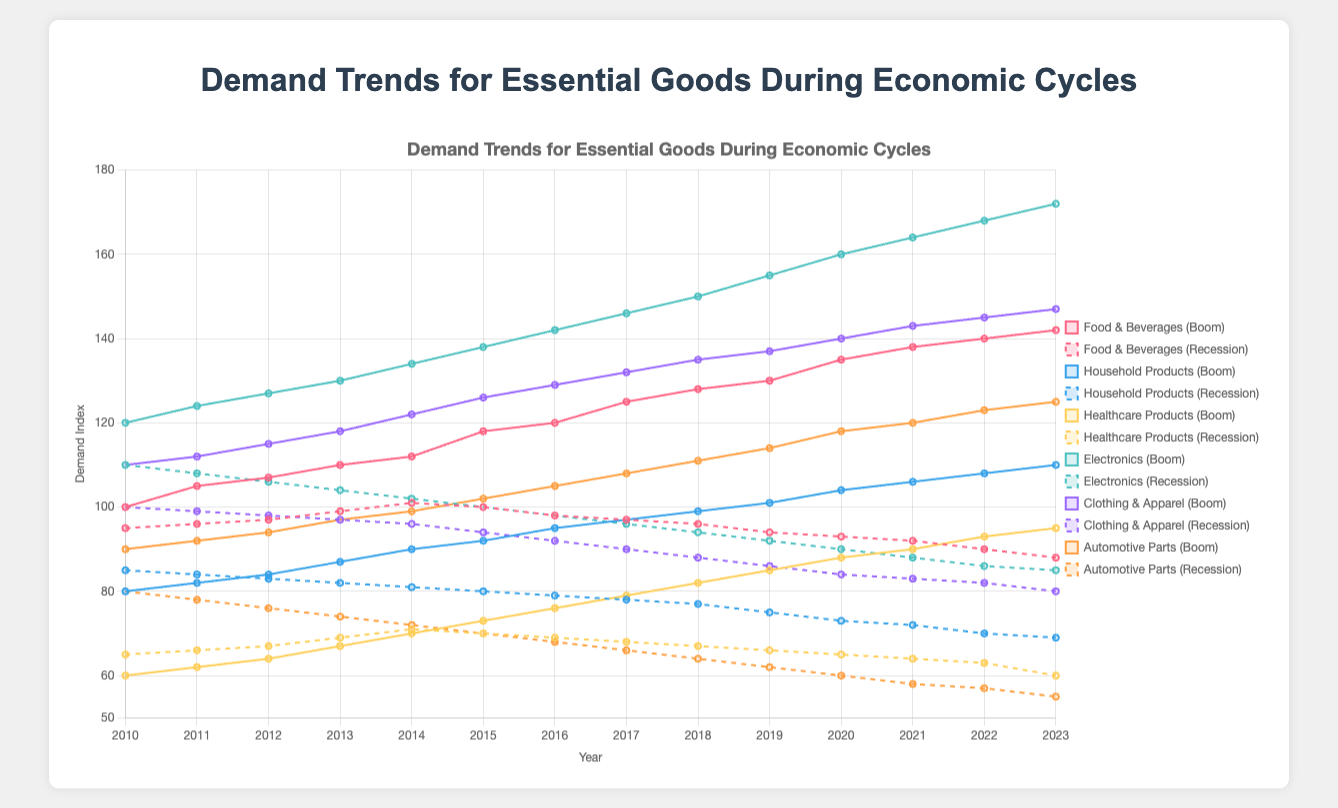What has been the general trend for the demand of Healthcare Products during economic booms? The demand for Healthcare Products during economic booms has consistently increased from 60 to 95 over the years 2010 to 2023. This steady rise indicates growing consumption in this category during favorable economic conditions.
Answer: Increasing How does the demand for Food & Beverages differ during economic booms and recessions by 2023? In 2023, the demand index for Food & Beverages during a boom is 142, whereas it is 88 during a recession. By subtracting the recession value from the boom value (142 - 88), the boom demand is 54 units higher than the recession demand.
Answer: 54 units higher during booms Which category has the highest demand index during an economic boom in 2023? Looking at the data for 2023, Electronics have the highest demand index of 172 during an economic boom compared to other categories.
Answer: Electronics When did the demand for Household Products during an economic recession start declining? The decline in demand for Household Products during an economic recession started after 2010, with a decrease from 85 in 2010 to 84 in 2011, followed by a consistent downward trend each year.
Answer: After 2010 Compare the rate of decline in demand for Clothing & Apparel during recessions between 2010 and 2023. The demand for Clothing & Apparel during recessions declined from 100 in 2010 to 80 in 2023. The difference is 20 units over the 14-year period, which means an average annual decline of approximately 1.43 units.
Answer: 1.43 units per year What is the demand for Automotive Parts during an economic recession in 2015, and how does it compare to that in 2023? In 2015, the demand index for Automotive Parts during a recession is 70, whereas in 2023, it is 55. The difference is 15 units, with demand being higher in 2015.
Answer: 15 units higher in 2015 Which years saw demand peak for Electronics during economic recessions, and what was the value? The demand for Electronics during economic recessions peaked at 110 in 2010 and then declined every subsequent year.
Answer: 2010, with a value of 110 What is the visual attribute for Healthcare Products during economic booms from 2010 to 2023? The line representing Healthcare Products during economic booms steadily ascends, starting from a value of 60 in 2010 and reaching 95 in 2023.
Answer: Steadily ascending For which product category is the demand least affected during economic recessions as of 2023? As of 2023, the least affected category in terms of demand during economic recessions is Healthcare Products, with demand dropping from 65 in 2010 to 60 in 2023, indicating relatively minor decreases.
Answer: Healthcare Products Which product category shows the most significant visual difference between economic boom and recession trends? Electronics show the most significant visual difference; the boom line rises steeply to 172 in 2023, while the recession line declines sharply to 85.
Answer: Electronics 